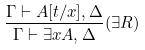Convert formula to latex. <formula><loc_0><loc_0><loc_500><loc_500>\frac { \Gamma \vdash A [ t / x ] , \Delta } { \Gamma \vdash \exists x A , \Delta } ( \exists R )</formula> 